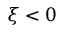<formula> <loc_0><loc_0><loc_500><loc_500>\xi < 0</formula> 